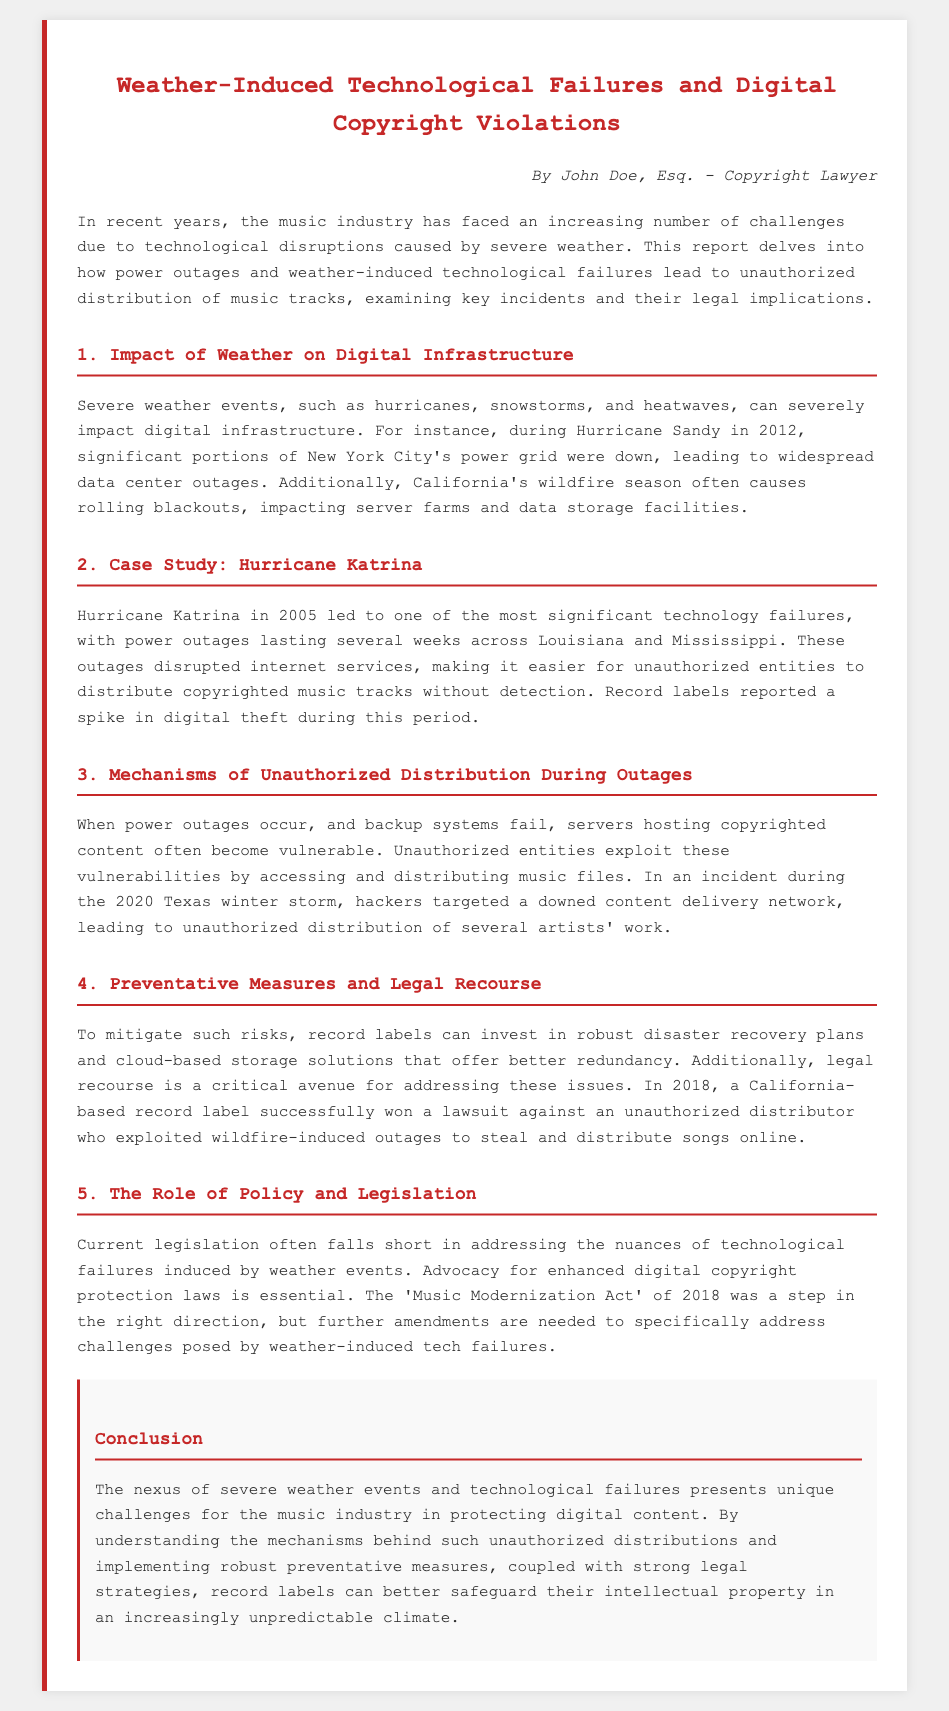What severe weather event caused power outages in New York City in 2012? The report mentions Hurricane Sandy as the severe weather event that caused power outages in New York City.
Answer: Hurricane Sandy Which hurricane led to significant technology failures in Louisiana and Mississippi in 2005? The document states that Hurricane Katrina led to significant technology failures in those states in 2005.
Answer: Hurricane Katrina What specific incident during the 2020 Texas winter storm involved unauthorized distribution? The report indicates that hackers targeted a downed content delivery network during the 2020 Texas winter storm.
Answer: Downed content delivery network What act was mentioned as a step towards digital copyright protection in 2018? The document refers to the 'Music Modernization Act' of 2018 as a step in the right direction for copyright protection.
Answer: Music Modernization Act What do record labels need to invest in to mitigate risks during technological failures? The report suggests that record labels should invest in robust disaster recovery plans and cloud-based storage solutions.
Answer: Disaster recovery plans and cloud-based storage solutions How did unauthorized entities exploit technology during Hurricane Katrina? Unauthorized entities exploited vulnerabilities created by power outages and internet disruptions to distribute copyrighted music.
Answer: Power outages and internet disruptions In what year did a California-based record label win a lawsuit related to digital theft? According to the document, the lawsuit was won in 2018 by a California-based record label against an unauthorized distributor.
Answer: 2018 